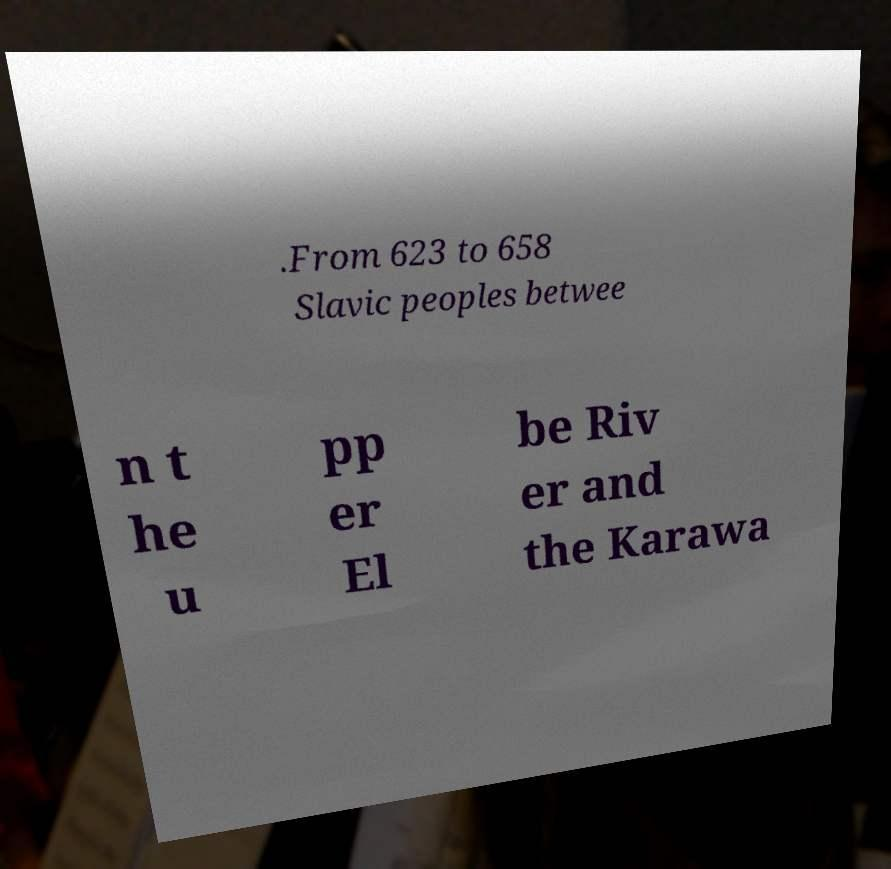Could you extract and type out the text from this image? .From 623 to 658 Slavic peoples betwee n t he u pp er El be Riv er and the Karawa 